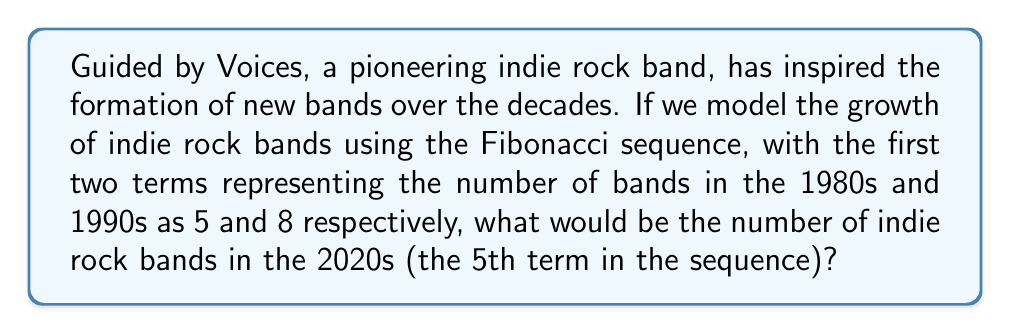Solve this math problem. Let's approach this step-by-step:

1) The Fibonacci sequence is defined as:
   $F_n = F_{n-1} + F_{n-2}$, where $F_1 = 5$ and $F_2 = 8$

2) Let's calculate each term:
   $F_1 = 5$ (1980s)
   $F_2 = 8$ (1990s)

3) For the 2000s (3rd term):
   $F_3 = F_2 + F_1 = 8 + 5 = 13$

4) For the 2010s (4th term):
   $F_4 = F_3 + F_2 = 13 + 8 = 21$

5) For the 2020s (5th term):
   $F_5 = F_4 + F_3 = 21 + 13 = 34$

Therefore, according to this model, the number of indie rock bands in the 2020s would be represented by the 5th term of the sequence, which is 34.
Answer: 34 